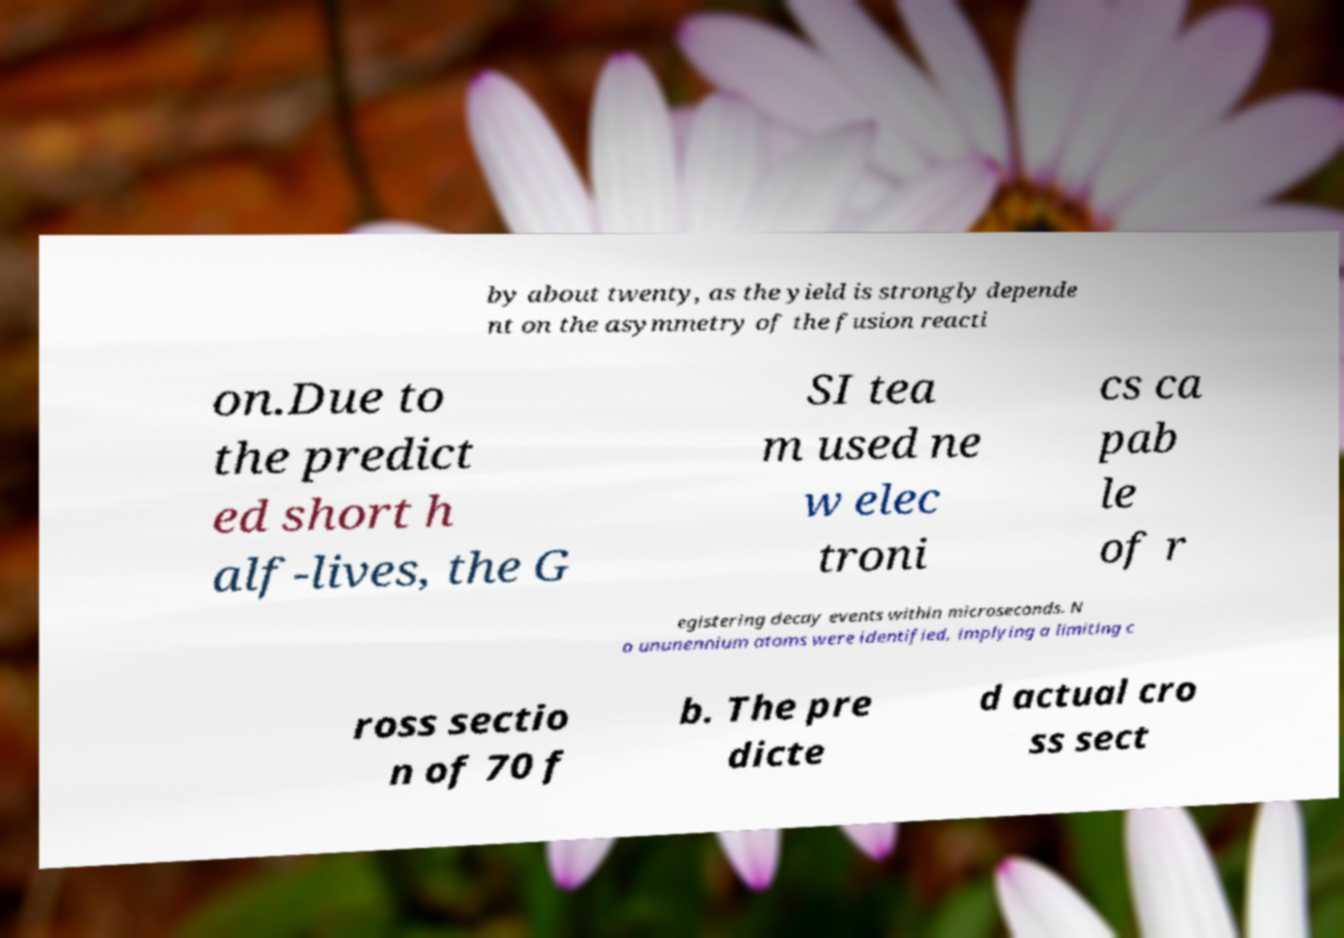Can you read and provide the text displayed in the image?This photo seems to have some interesting text. Can you extract and type it out for me? by about twenty, as the yield is strongly depende nt on the asymmetry of the fusion reacti on.Due to the predict ed short h alf-lives, the G SI tea m used ne w elec troni cs ca pab le of r egistering decay events within microseconds. N o ununennium atoms were identified, implying a limiting c ross sectio n of 70 f b. The pre dicte d actual cro ss sect 